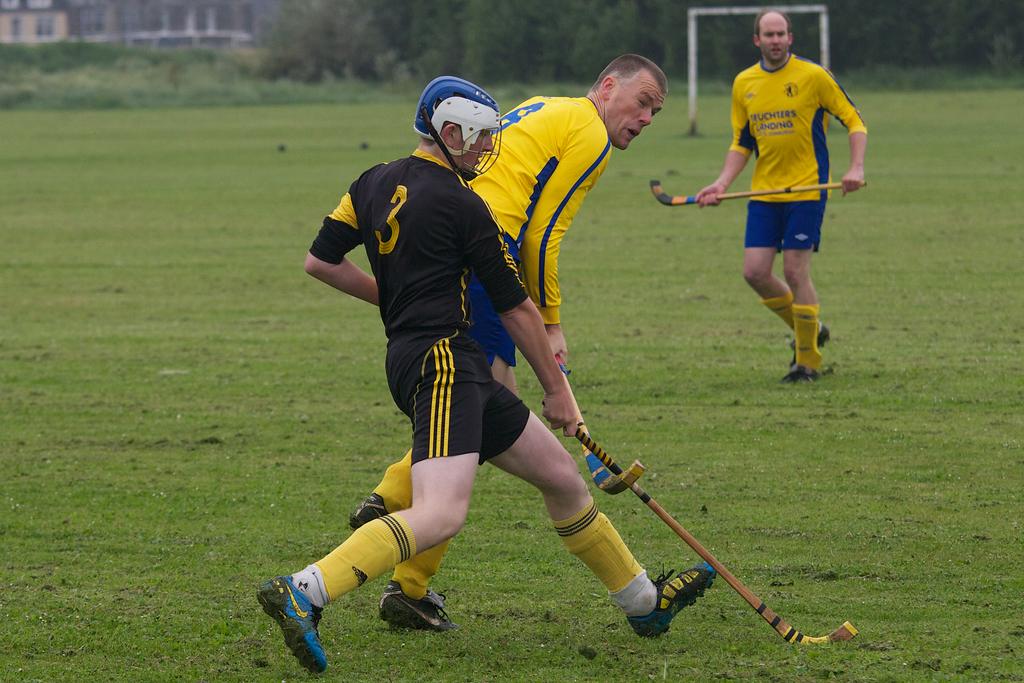What number is the player in black?
Your answer should be compact. 3. What is the sum of the numbers that are on the players backs ?
Your answer should be compact. 11. 